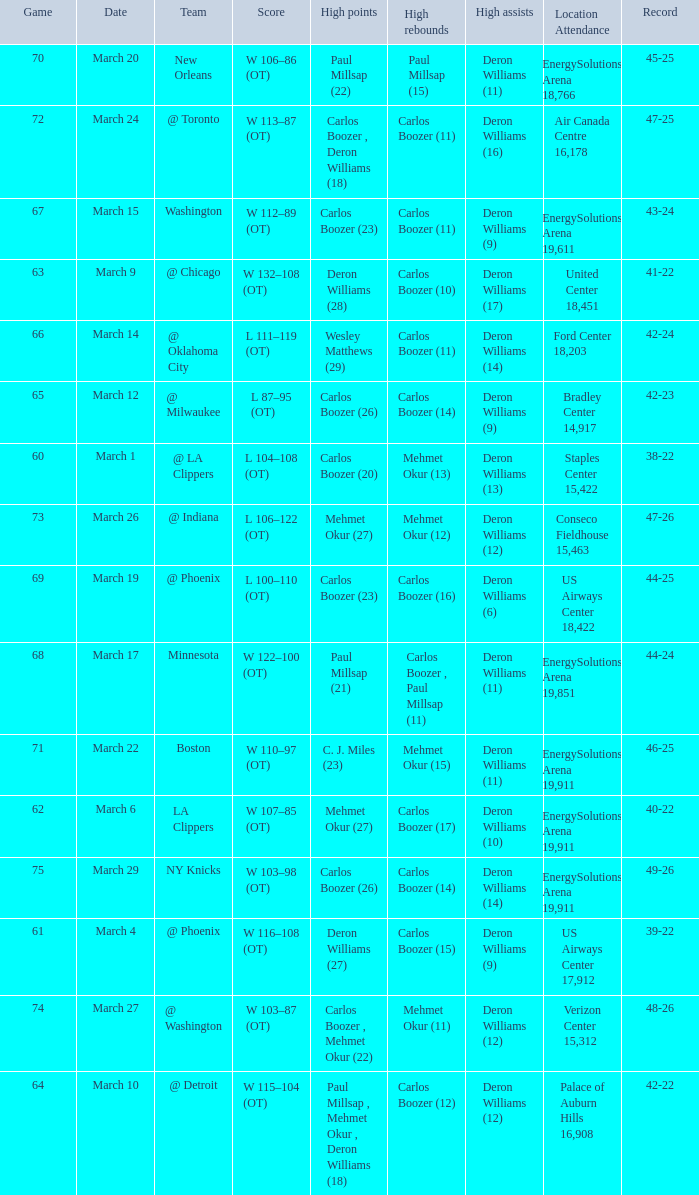At what location was the march 24 contest conducted? Air Canada Centre 16,178. 